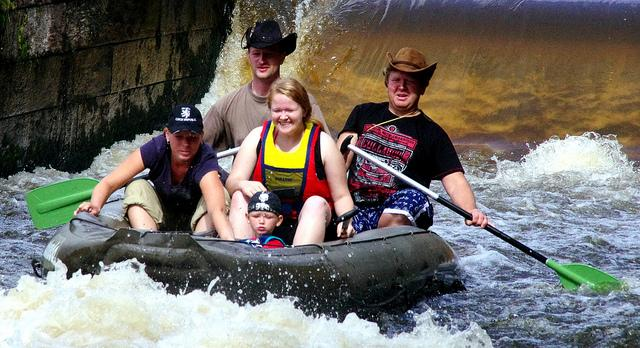What is this boat called?

Choices:
A) lifeboat
B) ship
C) inner tube
D) raft raft 